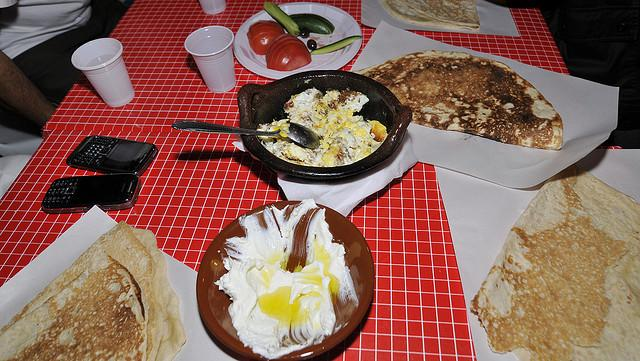This meal is likely for how many people? Please explain your reasoning. two. There is too much food for one person, but not really enough for more than two. 